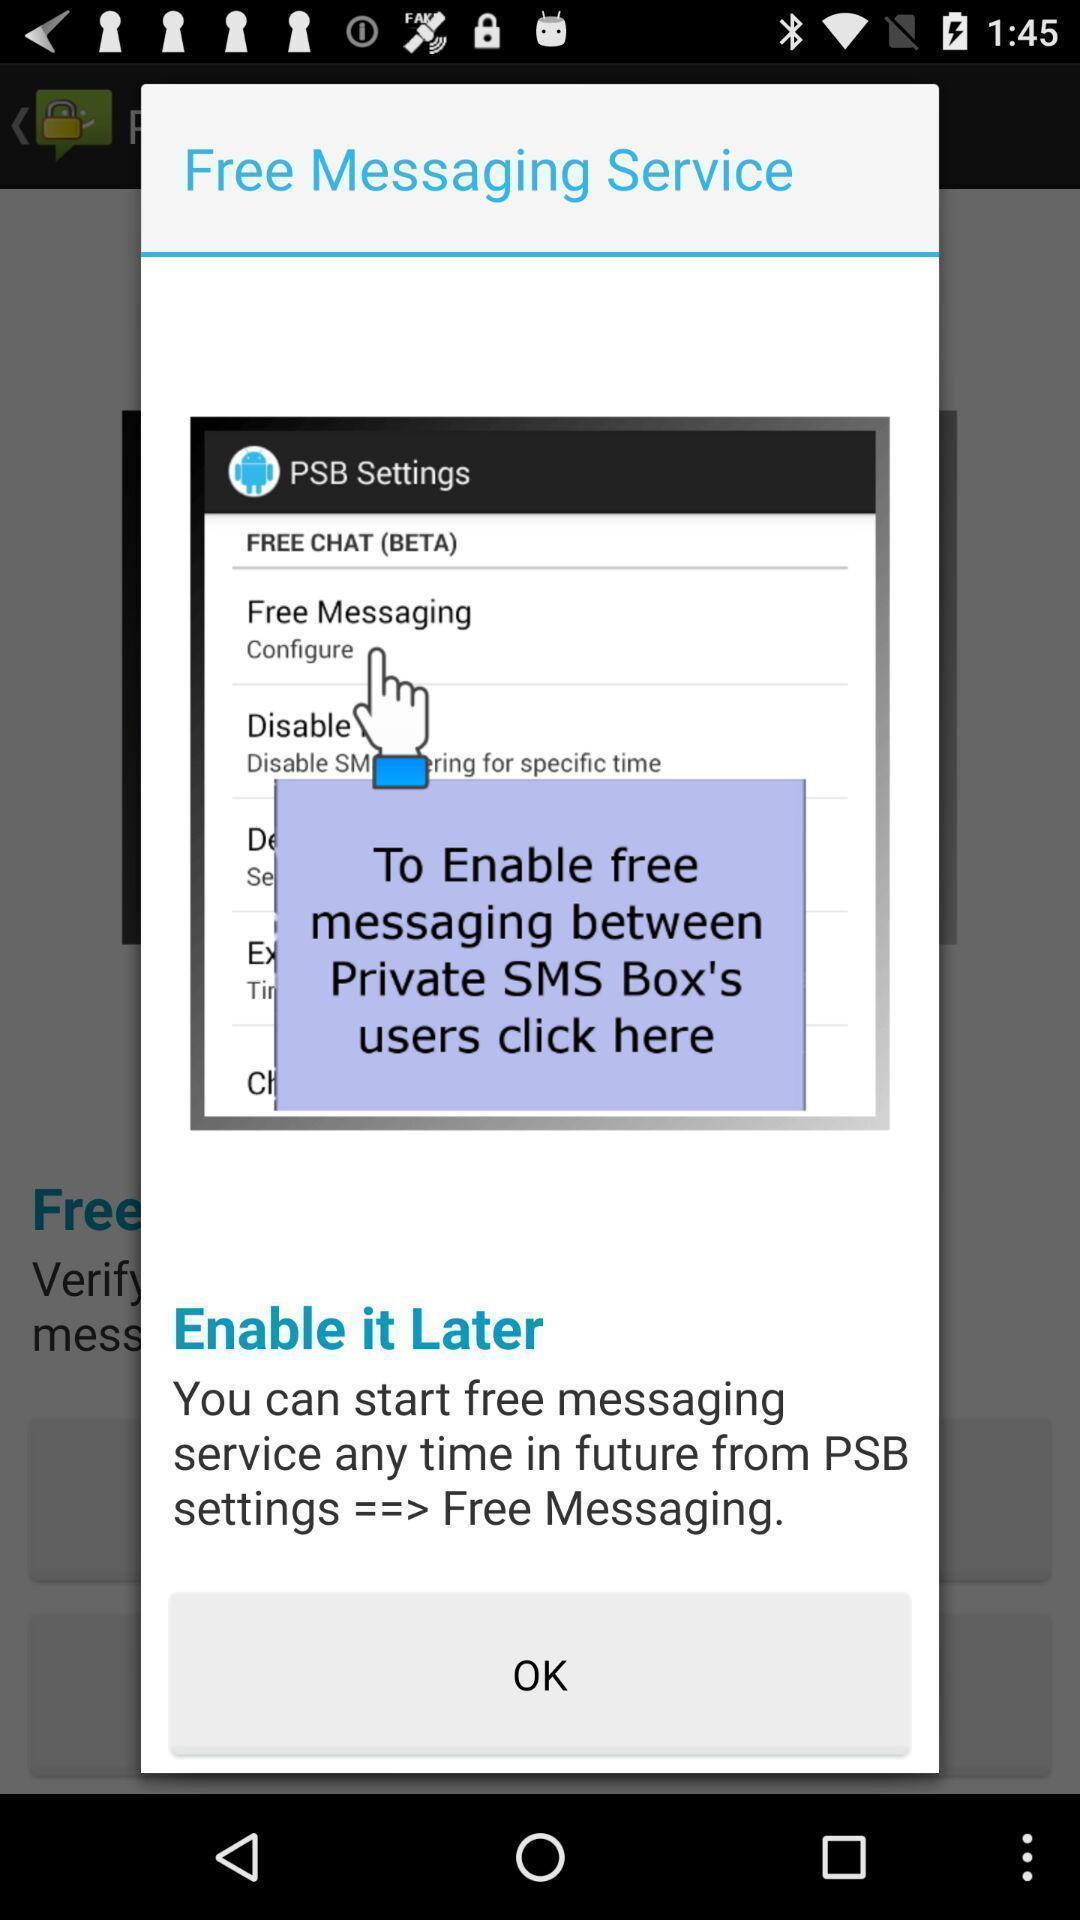Describe the key features of this screenshot. Popup of page for messaging service. 